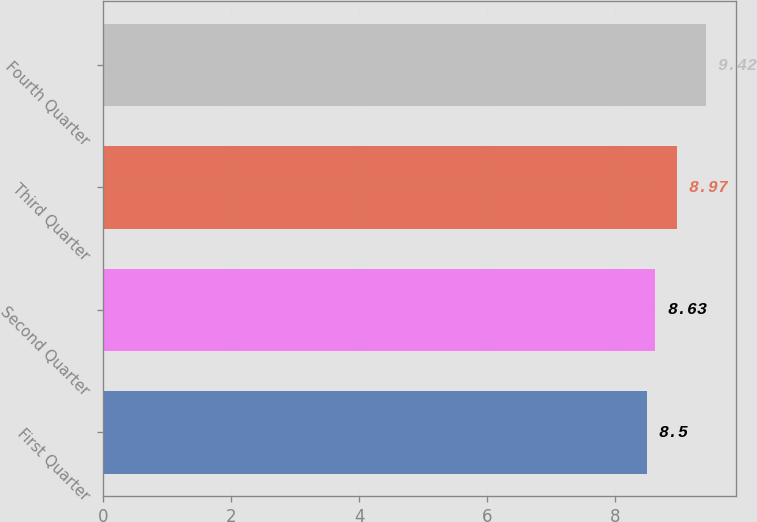Convert chart. <chart><loc_0><loc_0><loc_500><loc_500><bar_chart><fcel>First Quarter<fcel>Second Quarter<fcel>Third Quarter<fcel>Fourth Quarter<nl><fcel>8.5<fcel>8.63<fcel>8.97<fcel>9.42<nl></chart> 